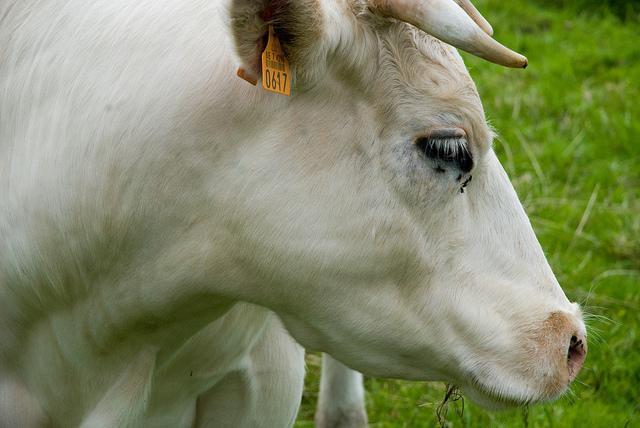How many people is in the canoe?
Give a very brief answer. 0. 